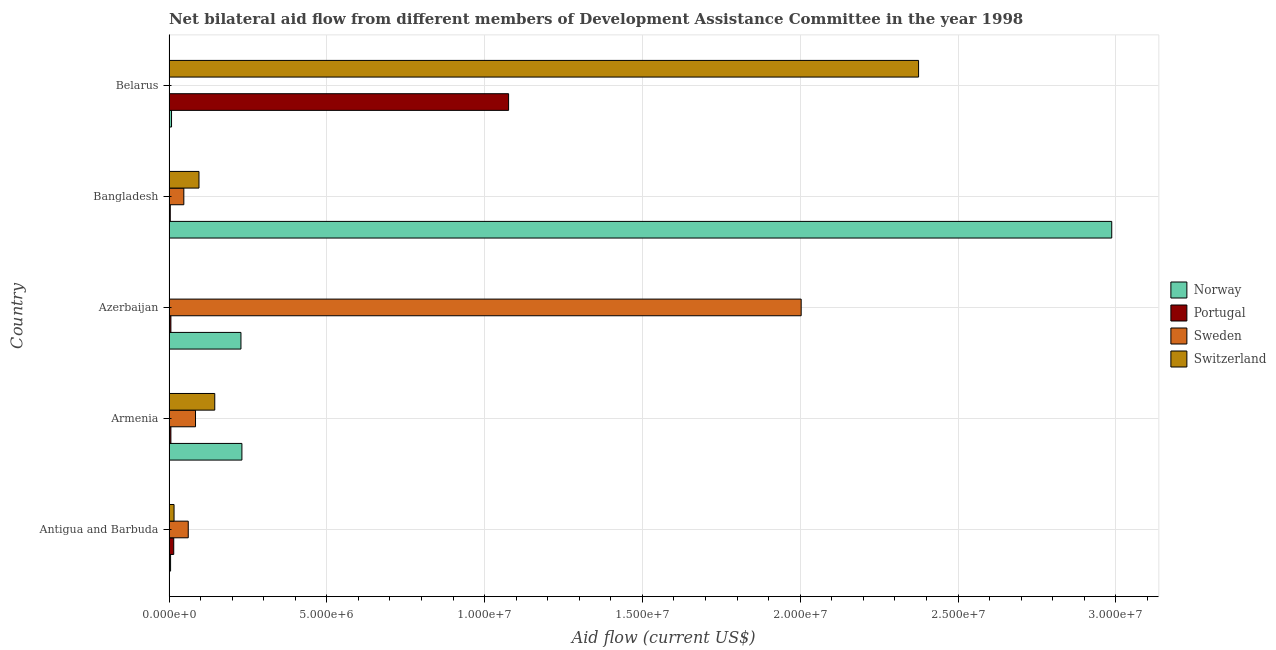How many different coloured bars are there?
Give a very brief answer. 4. How many bars are there on the 3rd tick from the top?
Your answer should be very brief. 4. How many bars are there on the 3rd tick from the bottom?
Your response must be concise. 4. What is the label of the 1st group of bars from the top?
Make the answer very short. Belarus. In how many cases, is the number of bars for a given country not equal to the number of legend labels?
Make the answer very short. 0. What is the amount of aid given by portugal in Armenia?
Keep it short and to the point. 6.00e+04. Across all countries, what is the maximum amount of aid given by portugal?
Offer a terse response. 1.08e+07. Across all countries, what is the minimum amount of aid given by switzerland?
Your response must be concise. 10000. In which country was the amount of aid given by portugal maximum?
Provide a succinct answer. Belarus. In which country was the amount of aid given by sweden minimum?
Offer a very short reply. Belarus. What is the total amount of aid given by norway in the graph?
Give a very brief answer. 3.46e+07. What is the difference between the amount of aid given by sweden in Azerbaijan and that in Belarus?
Make the answer very short. 2.00e+07. What is the difference between the amount of aid given by sweden in Bangladesh and the amount of aid given by switzerland in Armenia?
Provide a succinct answer. -9.80e+05. What is the average amount of aid given by switzerland per country?
Your answer should be very brief. 5.26e+06. What is the difference between the amount of aid given by portugal and amount of aid given by norway in Bangladesh?
Ensure brevity in your answer.  -2.98e+07. What is the ratio of the amount of aid given by switzerland in Armenia to that in Bangladesh?
Make the answer very short. 1.53. Is the amount of aid given by portugal in Antigua and Barbuda less than that in Armenia?
Provide a succinct answer. No. What is the difference between the highest and the second highest amount of aid given by sweden?
Your answer should be very brief. 1.92e+07. What is the difference between the highest and the lowest amount of aid given by portugal?
Make the answer very short. 1.07e+07. In how many countries, is the amount of aid given by switzerland greater than the average amount of aid given by switzerland taken over all countries?
Your answer should be very brief. 1. Is the sum of the amount of aid given by sweden in Antigua and Barbuda and Azerbaijan greater than the maximum amount of aid given by portugal across all countries?
Offer a very short reply. Yes. What does the 2nd bar from the bottom in Armenia represents?
Provide a succinct answer. Portugal. Is it the case that in every country, the sum of the amount of aid given by norway and amount of aid given by portugal is greater than the amount of aid given by sweden?
Your answer should be very brief. No. How many bars are there?
Ensure brevity in your answer.  20. Are all the bars in the graph horizontal?
Provide a succinct answer. Yes. What is the difference between two consecutive major ticks on the X-axis?
Give a very brief answer. 5.00e+06. Are the values on the major ticks of X-axis written in scientific E-notation?
Ensure brevity in your answer.  Yes. Does the graph contain grids?
Your answer should be compact. Yes. How many legend labels are there?
Keep it short and to the point. 4. How are the legend labels stacked?
Give a very brief answer. Vertical. What is the title of the graph?
Provide a short and direct response. Net bilateral aid flow from different members of Development Assistance Committee in the year 1998. Does "Public sector management" appear as one of the legend labels in the graph?
Give a very brief answer. No. What is the label or title of the X-axis?
Give a very brief answer. Aid flow (current US$). What is the label or title of the Y-axis?
Keep it short and to the point. Country. What is the Aid flow (current US$) in Portugal in Antigua and Barbuda?
Offer a very short reply. 1.50e+05. What is the Aid flow (current US$) of Switzerland in Antigua and Barbuda?
Provide a short and direct response. 1.60e+05. What is the Aid flow (current US$) of Norway in Armenia?
Provide a succinct answer. 2.31e+06. What is the Aid flow (current US$) of Sweden in Armenia?
Provide a short and direct response. 8.40e+05. What is the Aid flow (current US$) of Switzerland in Armenia?
Your response must be concise. 1.45e+06. What is the Aid flow (current US$) in Norway in Azerbaijan?
Provide a succinct answer. 2.28e+06. What is the Aid flow (current US$) of Sweden in Azerbaijan?
Ensure brevity in your answer.  2.00e+07. What is the Aid flow (current US$) in Switzerland in Azerbaijan?
Provide a succinct answer. 10000. What is the Aid flow (current US$) in Norway in Bangladesh?
Keep it short and to the point. 2.99e+07. What is the Aid flow (current US$) in Sweden in Bangladesh?
Offer a very short reply. 4.70e+05. What is the Aid flow (current US$) of Switzerland in Bangladesh?
Keep it short and to the point. 9.50e+05. What is the Aid flow (current US$) in Portugal in Belarus?
Keep it short and to the point. 1.08e+07. What is the Aid flow (current US$) in Switzerland in Belarus?
Your answer should be very brief. 2.38e+07. Across all countries, what is the maximum Aid flow (current US$) of Norway?
Give a very brief answer. 2.99e+07. Across all countries, what is the maximum Aid flow (current US$) in Portugal?
Give a very brief answer. 1.08e+07. Across all countries, what is the maximum Aid flow (current US$) in Sweden?
Provide a succinct answer. 2.00e+07. Across all countries, what is the maximum Aid flow (current US$) in Switzerland?
Your answer should be compact. 2.38e+07. Across all countries, what is the minimum Aid flow (current US$) of Norway?
Your answer should be very brief. 5.00e+04. Across all countries, what is the minimum Aid flow (current US$) of Portugal?
Your answer should be compact. 4.00e+04. Across all countries, what is the minimum Aid flow (current US$) of Sweden?
Your answer should be compact. 10000. What is the total Aid flow (current US$) in Norway in the graph?
Offer a very short reply. 3.46e+07. What is the total Aid flow (current US$) in Portugal in the graph?
Provide a succinct answer. 1.11e+07. What is the total Aid flow (current US$) in Sweden in the graph?
Offer a terse response. 2.20e+07. What is the total Aid flow (current US$) of Switzerland in the graph?
Provide a short and direct response. 2.63e+07. What is the difference between the Aid flow (current US$) of Norway in Antigua and Barbuda and that in Armenia?
Make the answer very short. -2.26e+06. What is the difference between the Aid flow (current US$) in Portugal in Antigua and Barbuda and that in Armenia?
Make the answer very short. 9.00e+04. What is the difference between the Aid flow (current US$) of Switzerland in Antigua and Barbuda and that in Armenia?
Keep it short and to the point. -1.29e+06. What is the difference between the Aid flow (current US$) in Norway in Antigua and Barbuda and that in Azerbaijan?
Offer a very short reply. -2.23e+06. What is the difference between the Aid flow (current US$) in Sweden in Antigua and Barbuda and that in Azerbaijan?
Provide a succinct answer. -1.94e+07. What is the difference between the Aid flow (current US$) of Norway in Antigua and Barbuda and that in Bangladesh?
Provide a short and direct response. -2.98e+07. What is the difference between the Aid flow (current US$) in Sweden in Antigua and Barbuda and that in Bangladesh?
Offer a very short reply. 1.40e+05. What is the difference between the Aid flow (current US$) in Switzerland in Antigua and Barbuda and that in Bangladesh?
Keep it short and to the point. -7.90e+05. What is the difference between the Aid flow (current US$) in Norway in Antigua and Barbuda and that in Belarus?
Your answer should be compact. -3.00e+04. What is the difference between the Aid flow (current US$) of Portugal in Antigua and Barbuda and that in Belarus?
Your response must be concise. -1.06e+07. What is the difference between the Aid flow (current US$) of Sweden in Antigua and Barbuda and that in Belarus?
Ensure brevity in your answer.  6.00e+05. What is the difference between the Aid flow (current US$) in Switzerland in Antigua and Barbuda and that in Belarus?
Offer a terse response. -2.36e+07. What is the difference between the Aid flow (current US$) of Sweden in Armenia and that in Azerbaijan?
Offer a terse response. -1.92e+07. What is the difference between the Aid flow (current US$) in Switzerland in Armenia and that in Azerbaijan?
Give a very brief answer. 1.44e+06. What is the difference between the Aid flow (current US$) of Norway in Armenia and that in Bangladesh?
Give a very brief answer. -2.76e+07. What is the difference between the Aid flow (current US$) of Sweden in Armenia and that in Bangladesh?
Offer a terse response. 3.70e+05. What is the difference between the Aid flow (current US$) of Norway in Armenia and that in Belarus?
Give a very brief answer. 2.23e+06. What is the difference between the Aid flow (current US$) in Portugal in Armenia and that in Belarus?
Your answer should be compact. -1.07e+07. What is the difference between the Aid flow (current US$) of Sweden in Armenia and that in Belarus?
Make the answer very short. 8.30e+05. What is the difference between the Aid flow (current US$) of Switzerland in Armenia and that in Belarus?
Ensure brevity in your answer.  -2.23e+07. What is the difference between the Aid flow (current US$) in Norway in Azerbaijan and that in Bangladesh?
Ensure brevity in your answer.  -2.76e+07. What is the difference between the Aid flow (current US$) in Sweden in Azerbaijan and that in Bangladesh?
Offer a very short reply. 1.96e+07. What is the difference between the Aid flow (current US$) of Switzerland in Azerbaijan and that in Bangladesh?
Your response must be concise. -9.40e+05. What is the difference between the Aid flow (current US$) of Norway in Azerbaijan and that in Belarus?
Give a very brief answer. 2.20e+06. What is the difference between the Aid flow (current US$) in Portugal in Azerbaijan and that in Belarus?
Your answer should be very brief. -1.07e+07. What is the difference between the Aid flow (current US$) of Sweden in Azerbaijan and that in Belarus?
Ensure brevity in your answer.  2.00e+07. What is the difference between the Aid flow (current US$) of Switzerland in Azerbaijan and that in Belarus?
Keep it short and to the point. -2.37e+07. What is the difference between the Aid flow (current US$) of Norway in Bangladesh and that in Belarus?
Offer a terse response. 2.98e+07. What is the difference between the Aid flow (current US$) of Portugal in Bangladesh and that in Belarus?
Provide a succinct answer. -1.07e+07. What is the difference between the Aid flow (current US$) in Switzerland in Bangladesh and that in Belarus?
Your answer should be compact. -2.28e+07. What is the difference between the Aid flow (current US$) in Norway in Antigua and Barbuda and the Aid flow (current US$) in Portugal in Armenia?
Provide a short and direct response. -10000. What is the difference between the Aid flow (current US$) in Norway in Antigua and Barbuda and the Aid flow (current US$) in Sweden in Armenia?
Provide a short and direct response. -7.90e+05. What is the difference between the Aid flow (current US$) of Norway in Antigua and Barbuda and the Aid flow (current US$) of Switzerland in Armenia?
Provide a short and direct response. -1.40e+06. What is the difference between the Aid flow (current US$) of Portugal in Antigua and Barbuda and the Aid flow (current US$) of Sweden in Armenia?
Offer a very short reply. -6.90e+05. What is the difference between the Aid flow (current US$) of Portugal in Antigua and Barbuda and the Aid flow (current US$) of Switzerland in Armenia?
Offer a terse response. -1.30e+06. What is the difference between the Aid flow (current US$) in Sweden in Antigua and Barbuda and the Aid flow (current US$) in Switzerland in Armenia?
Provide a succinct answer. -8.40e+05. What is the difference between the Aid flow (current US$) in Norway in Antigua and Barbuda and the Aid flow (current US$) in Sweden in Azerbaijan?
Provide a succinct answer. -2.00e+07. What is the difference between the Aid flow (current US$) in Norway in Antigua and Barbuda and the Aid flow (current US$) in Switzerland in Azerbaijan?
Your response must be concise. 4.00e+04. What is the difference between the Aid flow (current US$) of Portugal in Antigua and Barbuda and the Aid flow (current US$) of Sweden in Azerbaijan?
Ensure brevity in your answer.  -1.99e+07. What is the difference between the Aid flow (current US$) of Norway in Antigua and Barbuda and the Aid flow (current US$) of Portugal in Bangladesh?
Your response must be concise. 10000. What is the difference between the Aid flow (current US$) in Norway in Antigua and Barbuda and the Aid flow (current US$) in Sweden in Bangladesh?
Provide a succinct answer. -4.20e+05. What is the difference between the Aid flow (current US$) of Norway in Antigua and Barbuda and the Aid flow (current US$) of Switzerland in Bangladesh?
Ensure brevity in your answer.  -9.00e+05. What is the difference between the Aid flow (current US$) of Portugal in Antigua and Barbuda and the Aid flow (current US$) of Sweden in Bangladesh?
Provide a succinct answer. -3.20e+05. What is the difference between the Aid flow (current US$) in Portugal in Antigua and Barbuda and the Aid flow (current US$) in Switzerland in Bangladesh?
Offer a terse response. -8.00e+05. What is the difference between the Aid flow (current US$) in Sweden in Antigua and Barbuda and the Aid flow (current US$) in Switzerland in Bangladesh?
Keep it short and to the point. -3.40e+05. What is the difference between the Aid flow (current US$) of Norway in Antigua and Barbuda and the Aid flow (current US$) of Portugal in Belarus?
Make the answer very short. -1.07e+07. What is the difference between the Aid flow (current US$) in Norway in Antigua and Barbuda and the Aid flow (current US$) in Sweden in Belarus?
Make the answer very short. 4.00e+04. What is the difference between the Aid flow (current US$) in Norway in Antigua and Barbuda and the Aid flow (current US$) in Switzerland in Belarus?
Your response must be concise. -2.37e+07. What is the difference between the Aid flow (current US$) in Portugal in Antigua and Barbuda and the Aid flow (current US$) in Sweden in Belarus?
Ensure brevity in your answer.  1.40e+05. What is the difference between the Aid flow (current US$) of Portugal in Antigua and Barbuda and the Aid flow (current US$) of Switzerland in Belarus?
Your response must be concise. -2.36e+07. What is the difference between the Aid flow (current US$) in Sweden in Antigua and Barbuda and the Aid flow (current US$) in Switzerland in Belarus?
Your response must be concise. -2.31e+07. What is the difference between the Aid flow (current US$) of Norway in Armenia and the Aid flow (current US$) of Portugal in Azerbaijan?
Keep it short and to the point. 2.25e+06. What is the difference between the Aid flow (current US$) of Norway in Armenia and the Aid flow (current US$) of Sweden in Azerbaijan?
Your response must be concise. -1.77e+07. What is the difference between the Aid flow (current US$) in Norway in Armenia and the Aid flow (current US$) in Switzerland in Azerbaijan?
Your answer should be compact. 2.30e+06. What is the difference between the Aid flow (current US$) in Portugal in Armenia and the Aid flow (current US$) in Sweden in Azerbaijan?
Keep it short and to the point. -2.00e+07. What is the difference between the Aid flow (current US$) in Sweden in Armenia and the Aid flow (current US$) in Switzerland in Azerbaijan?
Offer a terse response. 8.30e+05. What is the difference between the Aid flow (current US$) of Norway in Armenia and the Aid flow (current US$) of Portugal in Bangladesh?
Make the answer very short. 2.27e+06. What is the difference between the Aid flow (current US$) of Norway in Armenia and the Aid flow (current US$) of Sweden in Bangladesh?
Provide a short and direct response. 1.84e+06. What is the difference between the Aid flow (current US$) of Norway in Armenia and the Aid flow (current US$) of Switzerland in Bangladesh?
Your answer should be compact. 1.36e+06. What is the difference between the Aid flow (current US$) of Portugal in Armenia and the Aid flow (current US$) of Sweden in Bangladesh?
Provide a short and direct response. -4.10e+05. What is the difference between the Aid flow (current US$) of Portugal in Armenia and the Aid flow (current US$) of Switzerland in Bangladesh?
Ensure brevity in your answer.  -8.90e+05. What is the difference between the Aid flow (current US$) of Sweden in Armenia and the Aid flow (current US$) of Switzerland in Bangladesh?
Ensure brevity in your answer.  -1.10e+05. What is the difference between the Aid flow (current US$) of Norway in Armenia and the Aid flow (current US$) of Portugal in Belarus?
Offer a very short reply. -8.45e+06. What is the difference between the Aid flow (current US$) in Norway in Armenia and the Aid flow (current US$) in Sweden in Belarus?
Offer a terse response. 2.30e+06. What is the difference between the Aid flow (current US$) in Norway in Armenia and the Aid flow (current US$) in Switzerland in Belarus?
Make the answer very short. -2.14e+07. What is the difference between the Aid flow (current US$) of Portugal in Armenia and the Aid flow (current US$) of Sweden in Belarus?
Your response must be concise. 5.00e+04. What is the difference between the Aid flow (current US$) of Portugal in Armenia and the Aid flow (current US$) of Switzerland in Belarus?
Make the answer very short. -2.37e+07. What is the difference between the Aid flow (current US$) in Sweden in Armenia and the Aid flow (current US$) in Switzerland in Belarus?
Your response must be concise. -2.29e+07. What is the difference between the Aid flow (current US$) of Norway in Azerbaijan and the Aid flow (current US$) of Portugal in Bangladesh?
Offer a terse response. 2.24e+06. What is the difference between the Aid flow (current US$) in Norway in Azerbaijan and the Aid flow (current US$) in Sweden in Bangladesh?
Keep it short and to the point. 1.81e+06. What is the difference between the Aid flow (current US$) of Norway in Azerbaijan and the Aid flow (current US$) of Switzerland in Bangladesh?
Your answer should be compact. 1.33e+06. What is the difference between the Aid flow (current US$) of Portugal in Azerbaijan and the Aid flow (current US$) of Sweden in Bangladesh?
Keep it short and to the point. -4.10e+05. What is the difference between the Aid flow (current US$) in Portugal in Azerbaijan and the Aid flow (current US$) in Switzerland in Bangladesh?
Ensure brevity in your answer.  -8.90e+05. What is the difference between the Aid flow (current US$) of Sweden in Azerbaijan and the Aid flow (current US$) of Switzerland in Bangladesh?
Ensure brevity in your answer.  1.91e+07. What is the difference between the Aid flow (current US$) in Norway in Azerbaijan and the Aid flow (current US$) in Portugal in Belarus?
Provide a succinct answer. -8.48e+06. What is the difference between the Aid flow (current US$) in Norway in Azerbaijan and the Aid flow (current US$) in Sweden in Belarus?
Provide a short and direct response. 2.27e+06. What is the difference between the Aid flow (current US$) of Norway in Azerbaijan and the Aid flow (current US$) of Switzerland in Belarus?
Your answer should be compact. -2.15e+07. What is the difference between the Aid flow (current US$) in Portugal in Azerbaijan and the Aid flow (current US$) in Switzerland in Belarus?
Keep it short and to the point. -2.37e+07. What is the difference between the Aid flow (current US$) of Sweden in Azerbaijan and the Aid flow (current US$) of Switzerland in Belarus?
Offer a very short reply. -3.72e+06. What is the difference between the Aid flow (current US$) of Norway in Bangladesh and the Aid flow (current US$) of Portugal in Belarus?
Your response must be concise. 1.91e+07. What is the difference between the Aid flow (current US$) of Norway in Bangladesh and the Aid flow (current US$) of Sweden in Belarus?
Keep it short and to the point. 2.99e+07. What is the difference between the Aid flow (current US$) of Norway in Bangladesh and the Aid flow (current US$) of Switzerland in Belarus?
Make the answer very short. 6.12e+06. What is the difference between the Aid flow (current US$) of Portugal in Bangladesh and the Aid flow (current US$) of Switzerland in Belarus?
Your answer should be compact. -2.37e+07. What is the difference between the Aid flow (current US$) of Sweden in Bangladesh and the Aid flow (current US$) of Switzerland in Belarus?
Give a very brief answer. -2.33e+07. What is the average Aid flow (current US$) in Norway per country?
Offer a very short reply. 6.92e+06. What is the average Aid flow (current US$) in Portugal per country?
Provide a short and direct response. 2.21e+06. What is the average Aid flow (current US$) in Sweden per country?
Offer a very short reply. 4.39e+06. What is the average Aid flow (current US$) in Switzerland per country?
Provide a succinct answer. 5.26e+06. What is the difference between the Aid flow (current US$) in Norway and Aid flow (current US$) in Portugal in Antigua and Barbuda?
Keep it short and to the point. -1.00e+05. What is the difference between the Aid flow (current US$) in Norway and Aid flow (current US$) in Sweden in Antigua and Barbuda?
Your answer should be very brief. -5.60e+05. What is the difference between the Aid flow (current US$) of Portugal and Aid flow (current US$) of Sweden in Antigua and Barbuda?
Provide a succinct answer. -4.60e+05. What is the difference between the Aid flow (current US$) of Norway and Aid flow (current US$) of Portugal in Armenia?
Give a very brief answer. 2.25e+06. What is the difference between the Aid flow (current US$) in Norway and Aid flow (current US$) in Sweden in Armenia?
Keep it short and to the point. 1.47e+06. What is the difference between the Aid flow (current US$) in Norway and Aid flow (current US$) in Switzerland in Armenia?
Your answer should be compact. 8.60e+05. What is the difference between the Aid flow (current US$) of Portugal and Aid flow (current US$) of Sweden in Armenia?
Provide a succinct answer. -7.80e+05. What is the difference between the Aid flow (current US$) in Portugal and Aid flow (current US$) in Switzerland in Armenia?
Give a very brief answer. -1.39e+06. What is the difference between the Aid flow (current US$) of Sweden and Aid flow (current US$) of Switzerland in Armenia?
Keep it short and to the point. -6.10e+05. What is the difference between the Aid flow (current US$) of Norway and Aid flow (current US$) of Portugal in Azerbaijan?
Provide a short and direct response. 2.22e+06. What is the difference between the Aid flow (current US$) in Norway and Aid flow (current US$) in Sweden in Azerbaijan?
Offer a very short reply. -1.78e+07. What is the difference between the Aid flow (current US$) of Norway and Aid flow (current US$) of Switzerland in Azerbaijan?
Offer a very short reply. 2.27e+06. What is the difference between the Aid flow (current US$) of Portugal and Aid flow (current US$) of Sweden in Azerbaijan?
Ensure brevity in your answer.  -2.00e+07. What is the difference between the Aid flow (current US$) of Sweden and Aid flow (current US$) of Switzerland in Azerbaijan?
Keep it short and to the point. 2.00e+07. What is the difference between the Aid flow (current US$) in Norway and Aid flow (current US$) in Portugal in Bangladesh?
Provide a short and direct response. 2.98e+07. What is the difference between the Aid flow (current US$) of Norway and Aid flow (current US$) of Sweden in Bangladesh?
Ensure brevity in your answer.  2.94e+07. What is the difference between the Aid flow (current US$) of Norway and Aid flow (current US$) of Switzerland in Bangladesh?
Your answer should be very brief. 2.89e+07. What is the difference between the Aid flow (current US$) of Portugal and Aid flow (current US$) of Sweden in Bangladesh?
Offer a very short reply. -4.30e+05. What is the difference between the Aid flow (current US$) of Portugal and Aid flow (current US$) of Switzerland in Bangladesh?
Offer a very short reply. -9.10e+05. What is the difference between the Aid flow (current US$) in Sweden and Aid flow (current US$) in Switzerland in Bangladesh?
Keep it short and to the point. -4.80e+05. What is the difference between the Aid flow (current US$) in Norway and Aid flow (current US$) in Portugal in Belarus?
Your answer should be compact. -1.07e+07. What is the difference between the Aid flow (current US$) in Norway and Aid flow (current US$) in Switzerland in Belarus?
Provide a short and direct response. -2.37e+07. What is the difference between the Aid flow (current US$) of Portugal and Aid flow (current US$) of Sweden in Belarus?
Ensure brevity in your answer.  1.08e+07. What is the difference between the Aid flow (current US$) of Portugal and Aid flow (current US$) of Switzerland in Belarus?
Offer a very short reply. -1.30e+07. What is the difference between the Aid flow (current US$) of Sweden and Aid flow (current US$) of Switzerland in Belarus?
Ensure brevity in your answer.  -2.37e+07. What is the ratio of the Aid flow (current US$) in Norway in Antigua and Barbuda to that in Armenia?
Offer a very short reply. 0.02. What is the ratio of the Aid flow (current US$) in Sweden in Antigua and Barbuda to that in Armenia?
Offer a terse response. 0.73. What is the ratio of the Aid flow (current US$) of Switzerland in Antigua and Barbuda to that in Armenia?
Give a very brief answer. 0.11. What is the ratio of the Aid flow (current US$) in Norway in Antigua and Barbuda to that in Azerbaijan?
Keep it short and to the point. 0.02. What is the ratio of the Aid flow (current US$) of Sweden in Antigua and Barbuda to that in Azerbaijan?
Offer a very short reply. 0.03. What is the ratio of the Aid flow (current US$) of Norway in Antigua and Barbuda to that in Bangladesh?
Provide a short and direct response. 0. What is the ratio of the Aid flow (current US$) of Portugal in Antigua and Barbuda to that in Bangladesh?
Keep it short and to the point. 3.75. What is the ratio of the Aid flow (current US$) of Sweden in Antigua and Barbuda to that in Bangladesh?
Provide a short and direct response. 1.3. What is the ratio of the Aid flow (current US$) of Switzerland in Antigua and Barbuda to that in Bangladesh?
Give a very brief answer. 0.17. What is the ratio of the Aid flow (current US$) of Portugal in Antigua and Barbuda to that in Belarus?
Offer a very short reply. 0.01. What is the ratio of the Aid flow (current US$) of Sweden in Antigua and Barbuda to that in Belarus?
Ensure brevity in your answer.  61. What is the ratio of the Aid flow (current US$) of Switzerland in Antigua and Barbuda to that in Belarus?
Your response must be concise. 0.01. What is the ratio of the Aid flow (current US$) in Norway in Armenia to that in Azerbaijan?
Offer a very short reply. 1.01. What is the ratio of the Aid flow (current US$) in Sweden in Armenia to that in Azerbaijan?
Give a very brief answer. 0.04. What is the ratio of the Aid flow (current US$) of Switzerland in Armenia to that in Azerbaijan?
Your response must be concise. 145. What is the ratio of the Aid flow (current US$) of Norway in Armenia to that in Bangladesh?
Your answer should be very brief. 0.08. What is the ratio of the Aid flow (current US$) in Sweden in Armenia to that in Bangladesh?
Your answer should be compact. 1.79. What is the ratio of the Aid flow (current US$) of Switzerland in Armenia to that in Bangladesh?
Give a very brief answer. 1.53. What is the ratio of the Aid flow (current US$) of Norway in Armenia to that in Belarus?
Offer a terse response. 28.88. What is the ratio of the Aid flow (current US$) in Portugal in Armenia to that in Belarus?
Provide a succinct answer. 0.01. What is the ratio of the Aid flow (current US$) in Sweden in Armenia to that in Belarus?
Your answer should be very brief. 84. What is the ratio of the Aid flow (current US$) of Switzerland in Armenia to that in Belarus?
Offer a terse response. 0.06. What is the ratio of the Aid flow (current US$) of Norway in Azerbaijan to that in Bangladesh?
Make the answer very short. 0.08. What is the ratio of the Aid flow (current US$) in Portugal in Azerbaijan to that in Bangladesh?
Your answer should be compact. 1.5. What is the ratio of the Aid flow (current US$) of Sweden in Azerbaijan to that in Bangladesh?
Your response must be concise. 42.62. What is the ratio of the Aid flow (current US$) in Switzerland in Azerbaijan to that in Bangladesh?
Your answer should be compact. 0.01. What is the ratio of the Aid flow (current US$) of Portugal in Azerbaijan to that in Belarus?
Keep it short and to the point. 0.01. What is the ratio of the Aid flow (current US$) of Sweden in Azerbaijan to that in Belarus?
Make the answer very short. 2003. What is the ratio of the Aid flow (current US$) of Norway in Bangladesh to that in Belarus?
Provide a short and direct response. 373.38. What is the ratio of the Aid flow (current US$) of Portugal in Bangladesh to that in Belarus?
Offer a terse response. 0. What is the ratio of the Aid flow (current US$) in Sweden in Bangladesh to that in Belarus?
Make the answer very short. 47. What is the ratio of the Aid flow (current US$) of Switzerland in Bangladesh to that in Belarus?
Make the answer very short. 0.04. What is the difference between the highest and the second highest Aid flow (current US$) of Norway?
Your response must be concise. 2.76e+07. What is the difference between the highest and the second highest Aid flow (current US$) in Portugal?
Offer a very short reply. 1.06e+07. What is the difference between the highest and the second highest Aid flow (current US$) of Sweden?
Give a very brief answer. 1.92e+07. What is the difference between the highest and the second highest Aid flow (current US$) of Switzerland?
Offer a very short reply. 2.23e+07. What is the difference between the highest and the lowest Aid flow (current US$) of Norway?
Your answer should be compact. 2.98e+07. What is the difference between the highest and the lowest Aid flow (current US$) of Portugal?
Ensure brevity in your answer.  1.07e+07. What is the difference between the highest and the lowest Aid flow (current US$) of Sweden?
Keep it short and to the point. 2.00e+07. What is the difference between the highest and the lowest Aid flow (current US$) of Switzerland?
Give a very brief answer. 2.37e+07. 